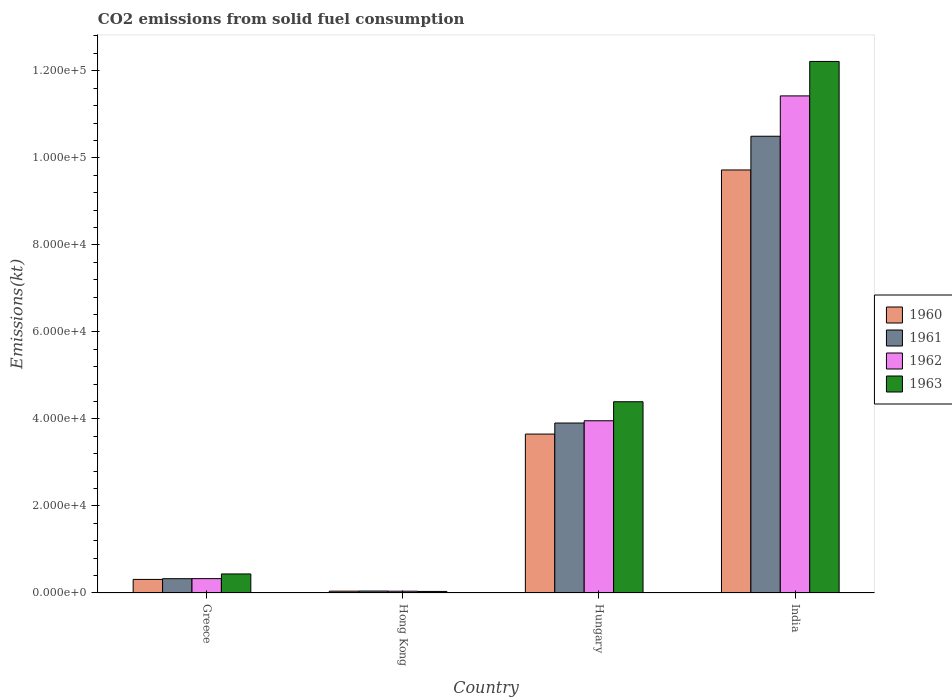How many different coloured bars are there?
Provide a succinct answer. 4. How many groups of bars are there?
Provide a short and direct response. 4. Are the number of bars per tick equal to the number of legend labels?
Ensure brevity in your answer.  Yes. How many bars are there on the 4th tick from the left?
Your answer should be compact. 4. In how many cases, is the number of bars for a given country not equal to the number of legend labels?
Provide a short and direct response. 0. What is the amount of CO2 emitted in 1961 in Hungary?
Your response must be concise. 3.91e+04. Across all countries, what is the maximum amount of CO2 emitted in 1962?
Make the answer very short. 1.14e+05. Across all countries, what is the minimum amount of CO2 emitted in 1961?
Offer a very short reply. 451.04. In which country was the amount of CO2 emitted in 1960 maximum?
Offer a terse response. India. In which country was the amount of CO2 emitted in 1961 minimum?
Your answer should be compact. Hong Kong. What is the total amount of CO2 emitted in 1960 in the graph?
Your response must be concise. 1.37e+05. What is the difference between the amount of CO2 emitted in 1963 in Hungary and that in India?
Offer a very short reply. -7.82e+04. What is the difference between the amount of CO2 emitted in 1961 in Greece and the amount of CO2 emitted in 1960 in India?
Offer a very short reply. -9.39e+04. What is the average amount of CO2 emitted in 1961 per country?
Offer a very short reply. 3.69e+04. What is the difference between the amount of CO2 emitted of/in 1961 and amount of CO2 emitted of/in 1963 in Greece?
Your answer should be very brief. -1089.1. In how many countries, is the amount of CO2 emitted in 1963 greater than 112000 kt?
Provide a short and direct response. 1. What is the ratio of the amount of CO2 emitted in 1961 in Hong Kong to that in Hungary?
Keep it short and to the point. 0.01. Is the amount of CO2 emitted in 1960 in Greece less than that in India?
Offer a terse response. Yes. What is the difference between the highest and the second highest amount of CO2 emitted in 1962?
Offer a terse response. -7.46e+04. What is the difference between the highest and the lowest amount of CO2 emitted in 1963?
Offer a terse response. 1.22e+05. In how many countries, is the amount of CO2 emitted in 1961 greater than the average amount of CO2 emitted in 1961 taken over all countries?
Ensure brevity in your answer.  2. Is it the case that in every country, the sum of the amount of CO2 emitted in 1960 and amount of CO2 emitted in 1961 is greater than the sum of amount of CO2 emitted in 1963 and amount of CO2 emitted in 1962?
Keep it short and to the point. No. What does the 2nd bar from the left in Hungary represents?
Your answer should be very brief. 1961. What does the 4th bar from the right in India represents?
Make the answer very short. 1960. How many bars are there?
Offer a very short reply. 16. How many countries are there in the graph?
Provide a succinct answer. 4. What is the difference between two consecutive major ticks on the Y-axis?
Make the answer very short. 2.00e+04. Are the values on the major ticks of Y-axis written in scientific E-notation?
Give a very brief answer. Yes. Does the graph contain grids?
Give a very brief answer. No. Where does the legend appear in the graph?
Ensure brevity in your answer.  Center right. How are the legend labels stacked?
Offer a very short reply. Vertical. What is the title of the graph?
Provide a short and direct response. CO2 emissions from solid fuel consumption. Does "1990" appear as one of the legend labels in the graph?
Offer a terse response. No. What is the label or title of the X-axis?
Offer a very short reply. Country. What is the label or title of the Y-axis?
Ensure brevity in your answer.  Emissions(kt). What is the Emissions(kt) of 1960 in Greece?
Ensure brevity in your answer.  3120.62. What is the Emissions(kt) of 1961 in Greece?
Your answer should be compact. 3285.63. What is the Emissions(kt) of 1962 in Greece?
Offer a very short reply. 3300.3. What is the Emissions(kt) of 1963 in Greece?
Make the answer very short. 4374.73. What is the Emissions(kt) of 1960 in Hong Kong?
Offer a very short reply. 418.04. What is the Emissions(kt) of 1961 in Hong Kong?
Ensure brevity in your answer.  451.04. What is the Emissions(kt) of 1962 in Hong Kong?
Keep it short and to the point. 410.7. What is the Emissions(kt) in 1963 in Hong Kong?
Give a very brief answer. 359.37. What is the Emissions(kt) of 1960 in Hungary?
Provide a succinct answer. 3.65e+04. What is the Emissions(kt) in 1961 in Hungary?
Provide a short and direct response. 3.91e+04. What is the Emissions(kt) of 1962 in Hungary?
Give a very brief answer. 3.96e+04. What is the Emissions(kt) of 1963 in Hungary?
Your answer should be very brief. 4.39e+04. What is the Emissions(kt) of 1960 in India?
Offer a very short reply. 9.72e+04. What is the Emissions(kt) in 1961 in India?
Keep it short and to the point. 1.05e+05. What is the Emissions(kt) of 1962 in India?
Give a very brief answer. 1.14e+05. What is the Emissions(kt) of 1963 in India?
Offer a terse response. 1.22e+05. Across all countries, what is the maximum Emissions(kt) in 1960?
Keep it short and to the point. 9.72e+04. Across all countries, what is the maximum Emissions(kt) of 1961?
Offer a very short reply. 1.05e+05. Across all countries, what is the maximum Emissions(kt) of 1962?
Keep it short and to the point. 1.14e+05. Across all countries, what is the maximum Emissions(kt) in 1963?
Provide a short and direct response. 1.22e+05. Across all countries, what is the minimum Emissions(kt) of 1960?
Keep it short and to the point. 418.04. Across all countries, what is the minimum Emissions(kt) in 1961?
Your answer should be compact. 451.04. Across all countries, what is the minimum Emissions(kt) of 1962?
Make the answer very short. 410.7. Across all countries, what is the minimum Emissions(kt) of 1963?
Keep it short and to the point. 359.37. What is the total Emissions(kt) in 1960 in the graph?
Your response must be concise. 1.37e+05. What is the total Emissions(kt) in 1961 in the graph?
Your answer should be very brief. 1.48e+05. What is the total Emissions(kt) in 1962 in the graph?
Your response must be concise. 1.58e+05. What is the total Emissions(kt) of 1963 in the graph?
Provide a short and direct response. 1.71e+05. What is the difference between the Emissions(kt) in 1960 in Greece and that in Hong Kong?
Make the answer very short. 2702.58. What is the difference between the Emissions(kt) in 1961 in Greece and that in Hong Kong?
Keep it short and to the point. 2834.59. What is the difference between the Emissions(kt) of 1962 in Greece and that in Hong Kong?
Your answer should be very brief. 2889.6. What is the difference between the Emissions(kt) in 1963 in Greece and that in Hong Kong?
Offer a terse response. 4015.36. What is the difference between the Emissions(kt) in 1960 in Greece and that in Hungary?
Your response must be concise. -3.34e+04. What is the difference between the Emissions(kt) in 1961 in Greece and that in Hungary?
Provide a succinct answer. -3.58e+04. What is the difference between the Emissions(kt) in 1962 in Greece and that in Hungary?
Provide a succinct answer. -3.63e+04. What is the difference between the Emissions(kt) in 1963 in Greece and that in Hungary?
Provide a short and direct response. -3.96e+04. What is the difference between the Emissions(kt) in 1960 in Greece and that in India?
Keep it short and to the point. -9.41e+04. What is the difference between the Emissions(kt) of 1961 in Greece and that in India?
Your answer should be very brief. -1.02e+05. What is the difference between the Emissions(kt) of 1962 in Greece and that in India?
Your answer should be very brief. -1.11e+05. What is the difference between the Emissions(kt) of 1963 in Greece and that in India?
Your answer should be very brief. -1.18e+05. What is the difference between the Emissions(kt) of 1960 in Hong Kong and that in Hungary?
Make the answer very short. -3.61e+04. What is the difference between the Emissions(kt) of 1961 in Hong Kong and that in Hungary?
Your response must be concise. -3.86e+04. What is the difference between the Emissions(kt) in 1962 in Hong Kong and that in Hungary?
Provide a succinct answer. -3.92e+04. What is the difference between the Emissions(kt) in 1963 in Hong Kong and that in Hungary?
Offer a terse response. -4.36e+04. What is the difference between the Emissions(kt) of 1960 in Hong Kong and that in India?
Your response must be concise. -9.68e+04. What is the difference between the Emissions(kt) in 1961 in Hong Kong and that in India?
Provide a short and direct response. -1.05e+05. What is the difference between the Emissions(kt) in 1962 in Hong Kong and that in India?
Keep it short and to the point. -1.14e+05. What is the difference between the Emissions(kt) in 1963 in Hong Kong and that in India?
Keep it short and to the point. -1.22e+05. What is the difference between the Emissions(kt) of 1960 in Hungary and that in India?
Offer a very short reply. -6.07e+04. What is the difference between the Emissions(kt) of 1961 in Hungary and that in India?
Provide a succinct answer. -6.59e+04. What is the difference between the Emissions(kt) in 1962 in Hungary and that in India?
Give a very brief answer. -7.46e+04. What is the difference between the Emissions(kt) in 1963 in Hungary and that in India?
Give a very brief answer. -7.82e+04. What is the difference between the Emissions(kt) of 1960 in Greece and the Emissions(kt) of 1961 in Hong Kong?
Provide a short and direct response. 2669.58. What is the difference between the Emissions(kt) of 1960 in Greece and the Emissions(kt) of 1962 in Hong Kong?
Your response must be concise. 2709.91. What is the difference between the Emissions(kt) of 1960 in Greece and the Emissions(kt) of 1963 in Hong Kong?
Keep it short and to the point. 2761.25. What is the difference between the Emissions(kt) of 1961 in Greece and the Emissions(kt) of 1962 in Hong Kong?
Provide a short and direct response. 2874.93. What is the difference between the Emissions(kt) in 1961 in Greece and the Emissions(kt) in 1963 in Hong Kong?
Your answer should be very brief. 2926.27. What is the difference between the Emissions(kt) of 1962 in Greece and the Emissions(kt) of 1963 in Hong Kong?
Make the answer very short. 2940.93. What is the difference between the Emissions(kt) of 1960 in Greece and the Emissions(kt) of 1961 in Hungary?
Keep it short and to the point. -3.59e+04. What is the difference between the Emissions(kt) of 1960 in Greece and the Emissions(kt) of 1962 in Hungary?
Ensure brevity in your answer.  -3.65e+04. What is the difference between the Emissions(kt) of 1960 in Greece and the Emissions(kt) of 1963 in Hungary?
Offer a very short reply. -4.08e+04. What is the difference between the Emissions(kt) in 1961 in Greece and the Emissions(kt) in 1962 in Hungary?
Ensure brevity in your answer.  -3.63e+04. What is the difference between the Emissions(kt) of 1961 in Greece and the Emissions(kt) of 1963 in Hungary?
Offer a terse response. -4.07e+04. What is the difference between the Emissions(kt) in 1962 in Greece and the Emissions(kt) in 1963 in Hungary?
Provide a short and direct response. -4.06e+04. What is the difference between the Emissions(kt) in 1960 in Greece and the Emissions(kt) in 1961 in India?
Offer a terse response. -1.02e+05. What is the difference between the Emissions(kt) in 1960 in Greece and the Emissions(kt) in 1962 in India?
Ensure brevity in your answer.  -1.11e+05. What is the difference between the Emissions(kt) of 1960 in Greece and the Emissions(kt) of 1963 in India?
Give a very brief answer. -1.19e+05. What is the difference between the Emissions(kt) of 1961 in Greece and the Emissions(kt) of 1962 in India?
Your response must be concise. -1.11e+05. What is the difference between the Emissions(kt) of 1961 in Greece and the Emissions(kt) of 1963 in India?
Offer a very short reply. -1.19e+05. What is the difference between the Emissions(kt) in 1962 in Greece and the Emissions(kt) in 1963 in India?
Give a very brief answer. -1.19e+05. What is the difference between the Emissions(kt) in 1960 in Hong Kong and the Emissions(kt) in 1961 in Hungary?
Your answer should be compact. -3.86e+04. What is the difference between the Emissions(kt) of 1960 in Hong Kong and the Emissions(kt) of 1962 in Hungary?
Make the answer very short. -3.92e+04. What is the difference between the Emissions(kt) in 1960 in Hong Kong and the Emissions(kt) in 1963 in Hungary?
Offer a very short reply. -4.35e+04. What is the difference between the Emissions(kt) of 1961 in Hong Kong and the Emissions(kt) of 1962 in Hungary?
Provide a short and direct response. -3.91e+04. What is the difference between the Emissions(kt) in 1961 in Hong Kong and the Emissions(kt) in 1963 in Hungary?
Keep it short and to the point. -4.35e+04. What is the difference between the Emissions(kt) of 1962 in Hong Kong and the Emissions(kt) of 1963 in Hungary?
Your answer should be very brief. -4.35e+04. What is the difference between the Emissions(kt) of 1960 in Hong Kong and the Emissions(kt) of 1961 in India?
Your answer should be compact. -1.05e+05. What is the difference between the Emissions(kt) in 1960 in Hong Kong and the Emissions(kt) in 1962 in India?
Provide a short and direct response. -1.14e+05. What is the difference between the Emissions(kt) of 1960 in Hong Kong and the Emissions(kt) of 1963 in India?
Ensure brevity in your answer.  -1.22e+05. What is the difference between the Emissions(kt) in 1961 in Hong Kong and the Emissions(kt) in 1962 in India?
Ensure brevity in your answer.  -1.14e+05. What is the difference between the Emissions(kt) in 1961 in Hong Kong and the Emissions(kt) in 1963 in India?
Offer a terse response. -1.22e+05. What is the difference between the Emissions(kt) in 1962 in Hong Kong and the Emissions(kt) in 1963 in India?
Ensure brevity in your answer.  -1.22e+05. What is the difference between the Emissions(kt) of 1960 in Hungary and the Emissions(kt) of 1961 in India?
Your answer should be very brief. -6.84e+04. What is the difference between the Emissions(kt) of 1960 in Hungary and the Emissions(kt) of 1962 in India?
Offer a very short reply. -7.77e+04. What is the difference between the Emissions(kt) in 1960 in Hungary and the Emissions(kt) in 1963 in India?
Your answer should be compact. -8.56e+04. What is the difference between the Emissions(kt) of 1961 in Hungary and the Emissions(kt) of 1962 in India?
Offer a very short reply. -7.52e+04. What is the difference between the Emissions(kt) of 1961 in Hungary and the Emissions(kt) of 1963 in India?
Keep it short and to the point. -8.31e+04. What is the difference between the Emissions(kt) in 1962 in Hungary and the Emissions(kt) in 1963 in India?
Your response must be concise. -8.26e+04. What is the average Emissions(kt) in 1960 per country?
Ensure brevity in your answer.  3.43e+04. What is the average Emissions(kt) in 1961 per country?
Make the answer very short. 3.69e+04. What is the average Emissions(kt) of 1962 per country?
Keep it short and to the point. 3.94e+04. What is the average Emissions(kt) of 1963 per country?
Your response must be concise. 4.27e+04. What is the difference between the Emissions(kt) of 1960 and Emissions(kt) of 1961 in Greece?
Ensure brevity in your answer.  -165.01. What is the difference between the Emissions(kt) of 1960 and Emissions(kt) of 1962 in Greece?
Your answer should be compact. -179.68. What is the difference between the Emissions(kt) of 1960 and Emissions(kt) of 1963 in Greece?
Your response must be concise. -1254.11. What is the difference between the Emissions(kt) of 1961 and Emissions(kt) of 1962 in Greece?
Keep it short and to the point. -14.67. What is the difference between the Emissions(kt) of 1961 and Emissions(kt) of 1963 in Greece?
Offer a terse response. -1089.1. What is the difference between the Emissions(kt) in 1962 and Emissions(kt) in 1963 in Greece?
Your answer should be very brief. -1074.43. What is the difference between the Emissions(kt) in 1960 and Emissions(kt) in 1961 in Hong Kong?
Offer a very short reply. -33. What is the difference between the Emissions(kt) of 1960 and Emissions(kt) of 1962 in Hong Kong?
Ensure brevity in your answer.  7.33. What is the difference between the Emissions(kt) of 1960 and Emissions(kt) of 1963 in Hong Kong?
Make the answer very short. 58.67. What is the difference between the Emissions(kt) of 1961 and Emissions(kt) of 1962 in Hong Kong?
Your answer should be very brief. 40.34. What is the difference between the Emissions(kt) of 1961 and Emissions(kt) of 1963 in Hong Kong?
Provide a succinct answer. 91.67. What is the difference between the Emissions(kt) of 1962 and Emissions(kt) of 1963 in Hong Kong?
Offer a terse response. 51.34. What is the difference between the Emissions(kt) in 1960 and Emissions(kt) in 1961 in Hungary?
Give a very brief answer. -2537.56. What is the difference between the Emissions(kt) in 1960 and Emissions(kt) in 1962 in Hungary?
Ensure brevity in your answer.  -3058.28. What is the difference between the Emissions(kt) of 1960 and Emissions(kt) of 1963 in Hungary?
Ensure brevity in your answer.  -7429.34. What is the difference between the Emissions(kt) in 1961 and Emissions(kt) in 1962 in Hungary?
Ensure brevity in your answer.  -520.71. What is the difference between the Emissions(kt) in 1961 and Emissions(kt) in 1963 in Hungary?
Make the answer very short. -4891.78. What is the difference between the Emissions(kt) of 1962 and Emissions(kt) of 1963 in Hungary?
Provide a short and direct response. -4371.06. What is the difference between the Emissions(kt) in 1960 and Emissions(kt) in 1961 in India?
Your answer should be very brief. -7748.37. What is the difference between the Emissions(kt) of 1960 and Emissions(kt) of 1962 in India?
Make the answer very short. -1.70e+04. What is the difference between the Emissions(kt) in 1960 and Emissions(kt) in 1963 in India?
Ensure brevity in your answer.  -2.49e+04. What is the difference between the Emissions(kt) in 1961 and Emissions(kt) in 1962 in India?
Make the answer very short. -9270.18. What is the difference between the Emissions(kt) of 1961 and Emissions(kt) of 1963 in India?
Your answer should be compact. -1.72e+04. What is the difference between the Emissions(kt) in 1962 and Emissions(kt) in 1963 in India?
Provide a succinct answer. -7917.05. What is the ratio of the Emissions(kt) of 1960 in Greece to that in Hong Kong?
Offer a terse response. 7.46. What is the ratio of the Emissions(kt) in 1961 in Greece to that in Hong Kong?
Give a very brief answer. 7.28. What is the ratio of the Emissions(kt) in 1962 in Greece to that in Hong Kong?
Provide a succinct answer. 8.04. What is the ratio of the Emissions(kt) in 1963 in Greece to that in Hong Kong?
Offer a very short reply. 12.17. What is the ratio of the Emissions(kt) in 1960 in Greece to that in Hungary?
Your answer should be compact. 0.09. What is the ratio of the Emissions(kt) of 1961 in Greece to that in Hungary?
Provide a short and direct response. 0.08. What is the ratio of the Emissions(kt) in 1962 in Greece to that in Hungary?
Make the answer very short. 0.08. What is the ratio of the Emissions(kt) in 1963 in Greece to that in Hungary?
Your answer should be compact. 0.1. What is the ratio of the Emissions(kt) in 1960 in Greece to that in India?
Keep it short and to the point. 0.03. What is the ratio of the Emissions(kt) of 1961 in Greece to that in India?
Ensure brevity in your answer.  0.03. What is the ratio of the Emissions(kt) in 1962 in Greece to that in India?
Your response must be concise. 0.03. What is the ratio of the Emissions(kt) of 1963 in Greece to that in India?
Your answer should be very brief. 0.04. What is the ratio of the Emissions(kt) in 1960 in Hong Kong to that in Hungary?
Give a very brief answer. 0.01. What is the ratio of the Emissions(kt) in 1961 in Hong Kong to that in Hungary?
Ensure brevity in your answer.  0.01. What is the ratio of the Emissions(kt) in 1962 in Hong Kong to that in Hungary?
Give a very brief answer. 0.01. What is the ratio of the Emissions(kt) of 1963 in Hong Kong to that in Hungary?
Your answer should be compact. 0.01. What is the ratio of the Emissions(kt) in 1960 in Hong Kong to that in India?
Make the answer very short. 0. What is the ratio of the Emissions(kt) in 1961 in Hong Kong to that in India?
Keep it short and to the point. 0. What is the ratio of the Emissions(kt) of 1962 in Hong Kong to that in India?
Offer a very short reply. 0. What is the ratio of the Emissions(kt) of 1963 in Hong Kong to that in India?
Give a very brief answer. 0. What is the ratio of the Emissions(kt) of 1960 in Hungary to that in India?
Your response must be concise. 0.38. What is the ratio of the Emissions(kt) of 1961 in Hungary to that in India?
Give a very brief answer. 0.37. What is the ratio of the Emissions(kt) in 1962 in Hungary to that in India?
Make the answer very short. 0.35. What is the ratio of the Emissions(kt) in 1963 in Hungary to that in India?
Your answer should be compact. 0.36. What is the difference between the highest and the second highest Emissions(kt) of 1960?
Make the answer very short. 6.07e+04. What is the difference between the highest and the second highest Emissions(kt) in 1961?
Provide a succinct answer. 6.59e+04. What is the difference between the highest and the second highest Emissions(kt) of 1962?
Provide a short and direct response. 7.46e+04. What is the difference between the highest and the second highest Emissions(kt) in 1963?
Keep it short and to the point. 7.82e+04. What is the difference between the highest and the lowest Emissions(kt) of 1960?
Keep it short and to the point. 9.68e+04. What is the difference between the highest and the lowest Emissions(kt) in 1961?
Offer a very short reply. 1.05e+05. What is the difference between the highest and the lowest Emissions(kt) of 1962?
Provide a succinct answer. 1.14e+05. What is the difference between the highest and the lowest Emissions(kt) of 1963?
Offer a very short reply. 1.22e+05. 